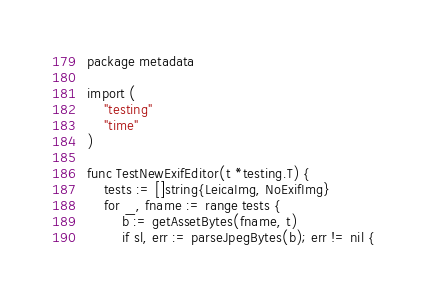<code> <loc_0><loc_0><loc_500><loc_500><_Go_>package metadata

import (
	"testing"
	"time"
)

func TestNewExifEditor(t *testing.T) {
	tests := []string{LeicaImg, NoExifImg}
	for _, fname := range tests {
		b := getAssetBytes(fname, t)
		if sl, err := parseJpegBytes(b); err != nil {</code> 